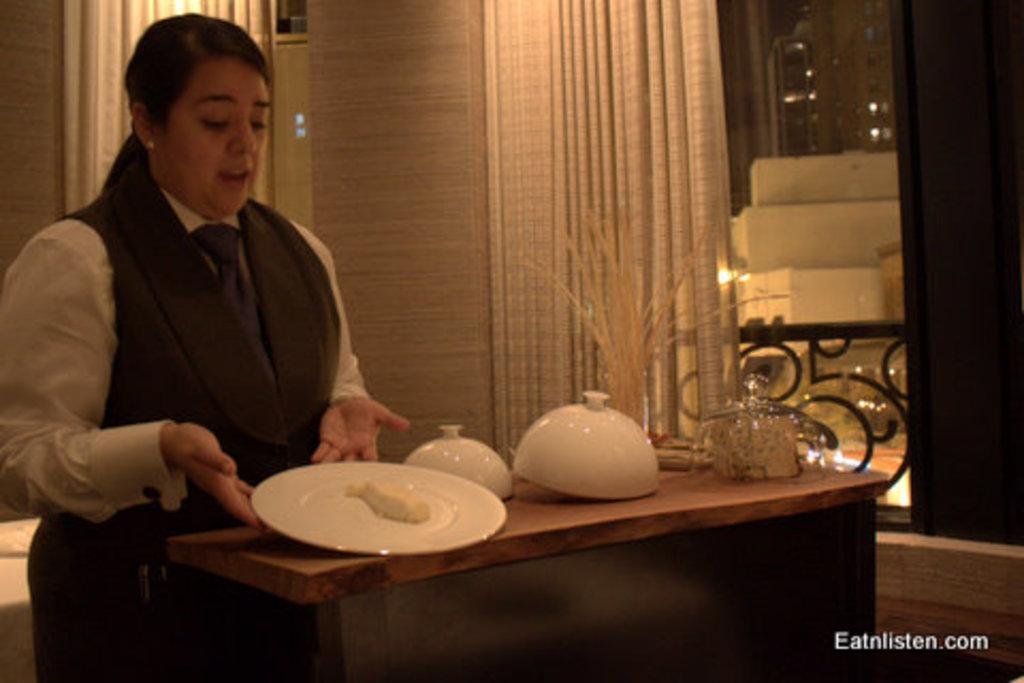What objects are on the table in the image? There are bowls and a plate on the table in the image. What is the woman doing with the plate? The woman is holding the plate with her hands. What can be seen in the background of the image? There are curtains in the background. What is the price of the friction between the plate and the woman's hands in the image? There is no mention of friction or price in the image, as it features a woman holding a plate and bowls on a table with curtains in the background. 